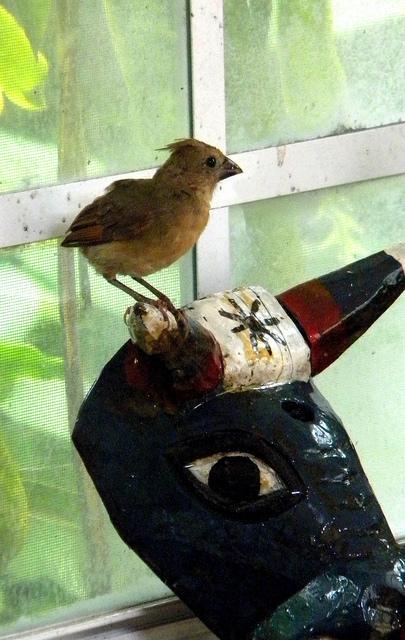What is the color of the birds?
Keep it brief. Brown. Is the bird balanced?
Be succinct. Yes. On top of what is the bird sitting?
Keep it brief. Statue. 